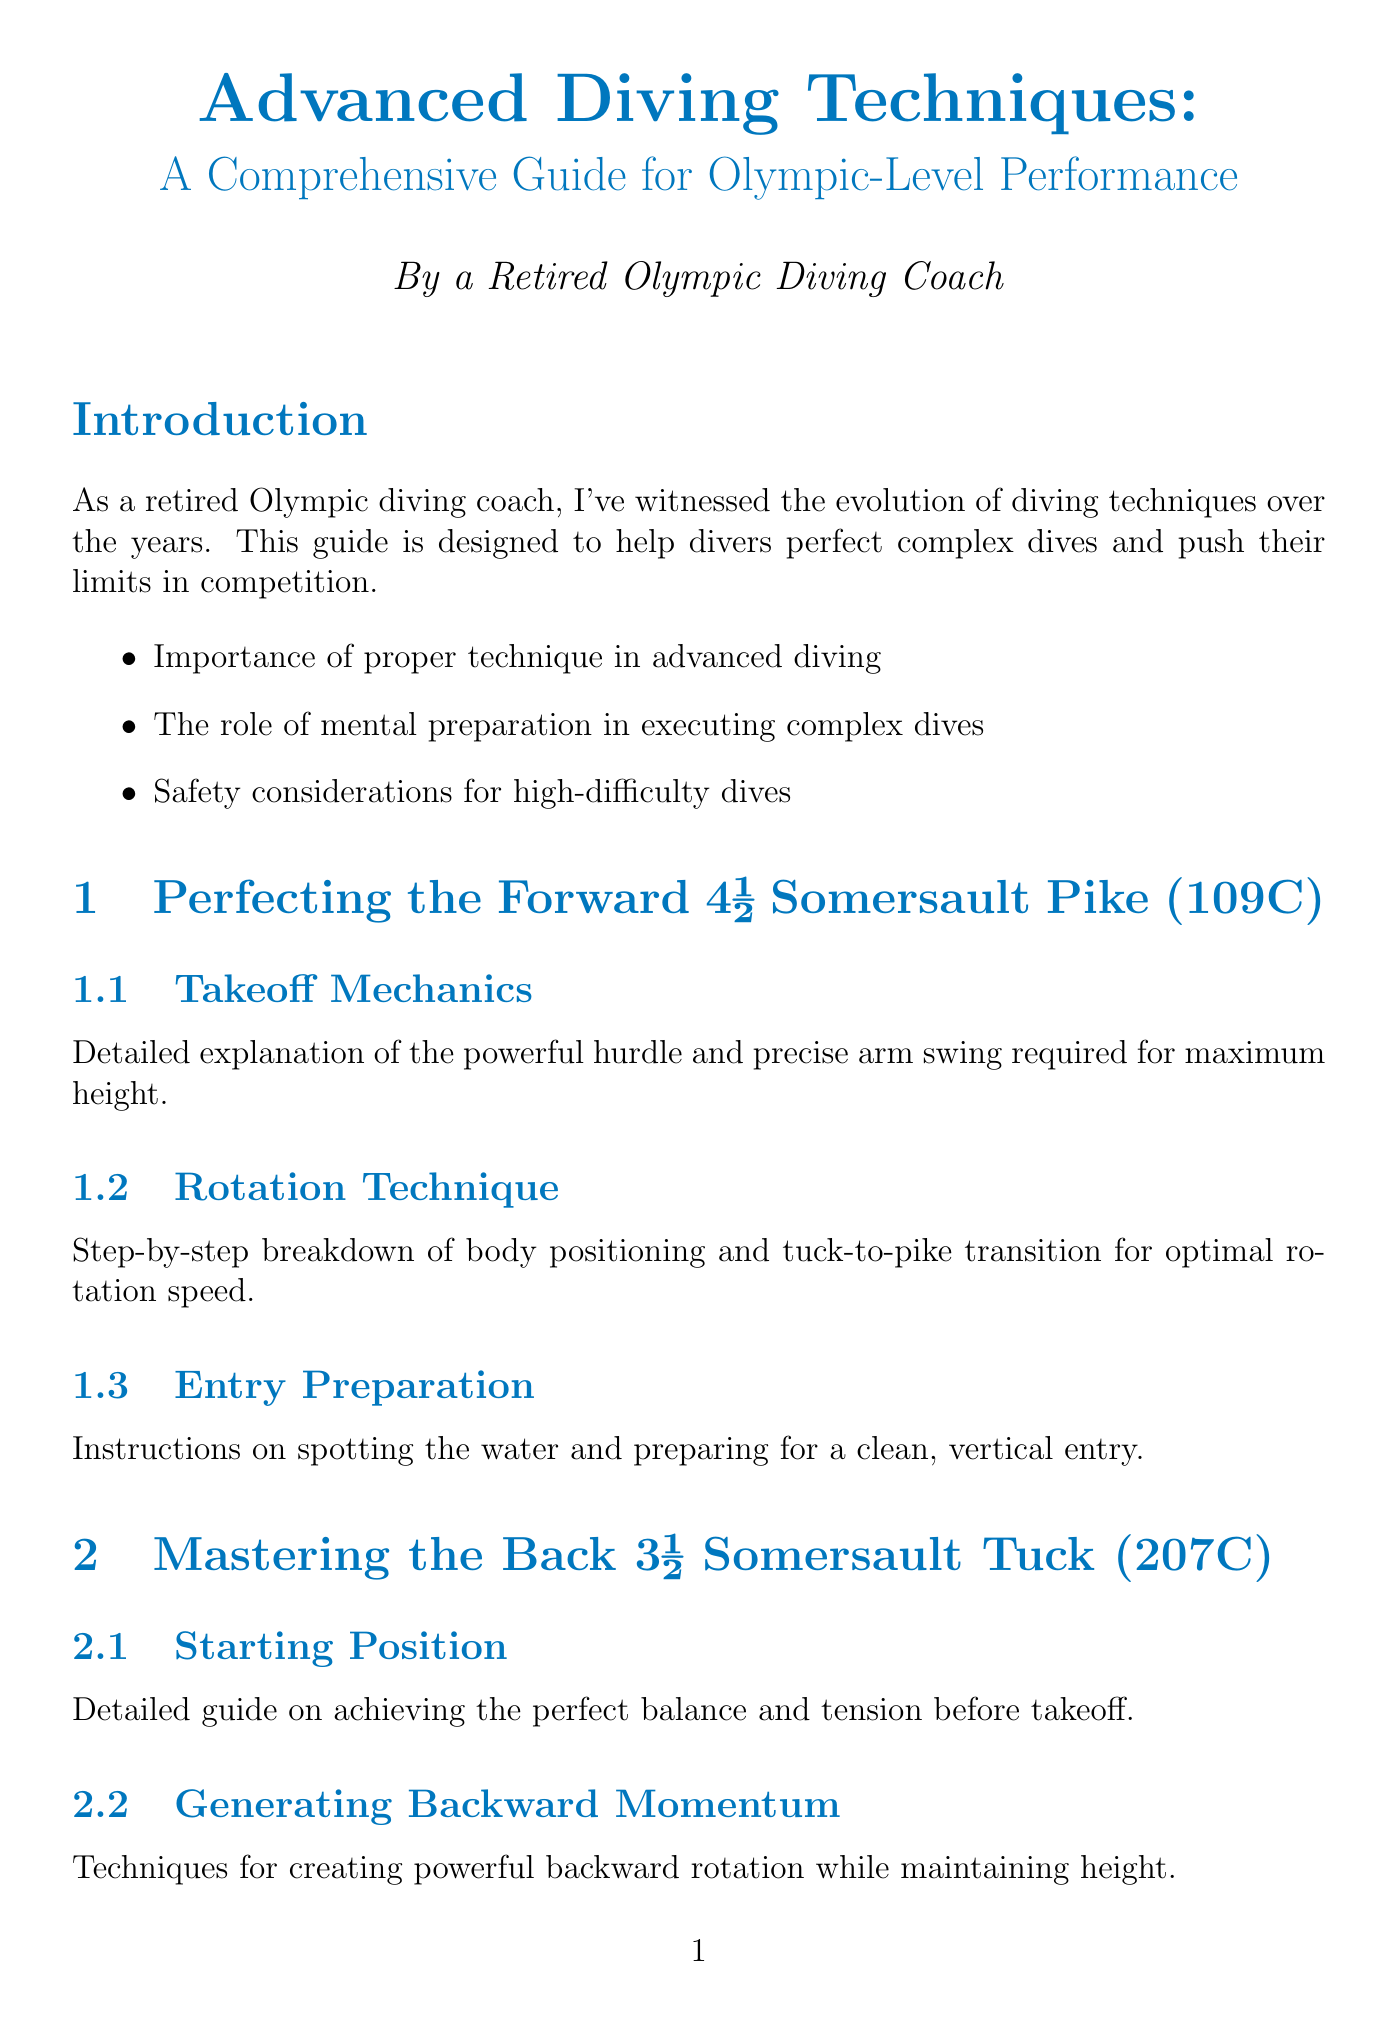What is the title of the guide? The title of the guide is found at the beginning of the document, which provides an overview of its content.
Answer: Advanced Diving Techniques: A Comprehensive Guide for Olympic-Level Performance What dive technique is covered in Chapter 1? The first chapter focuses on a specific diving technique, outlined in the section headers.
Answer: Perfecting the Forward 4½ Somersault Pike (109C) How many sections are in the chapter on the Back 3½ Somersault Tuck? The number of sections can be counted by listing those under the relevant chapter.
Answer: 3 What is a key point mentioned in the Safety Considerations? The safety considerations highlight important precautions that divers must take before practicing.
Answer: Proper pool depth and clearance Which visualization technique is suggested for mental preparation? Mental preparation techniques are detailed in a training tips section, including a specific method.
Answer: Visualization What is the main focus in the section about Takeoff Mechanics? The section describes critical elements necessary for executing the dive successfully.
Answer: Powerful hurdle and precise arm swing What specific technical flaw identification method is discussed? The guide mentions a method used to improve diving techniques through analysis.
Answer: Video Analysis What is emphasized as crucial for high-difficulty dives? The document outlines essential elements that are necessary for safety during advanced dives.
Answer: Safety considerations 